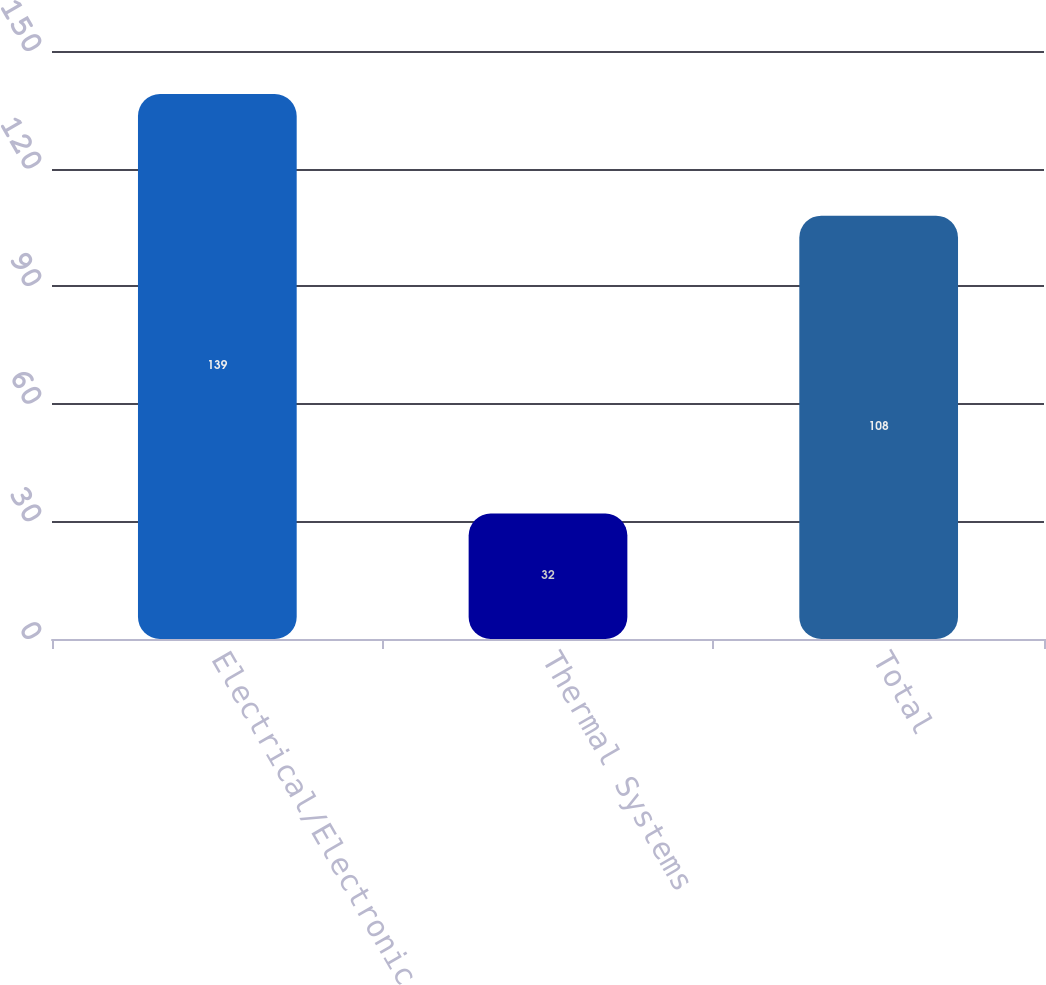<chart> <loc_0><loc_0><loc_500><loc_500><bar_chart><fcel>Electrical/Electronic<fcel>Thermal Systems<fcel>Total<nl><fcel>139<fcel>32<fcel>108<nl></chart> 